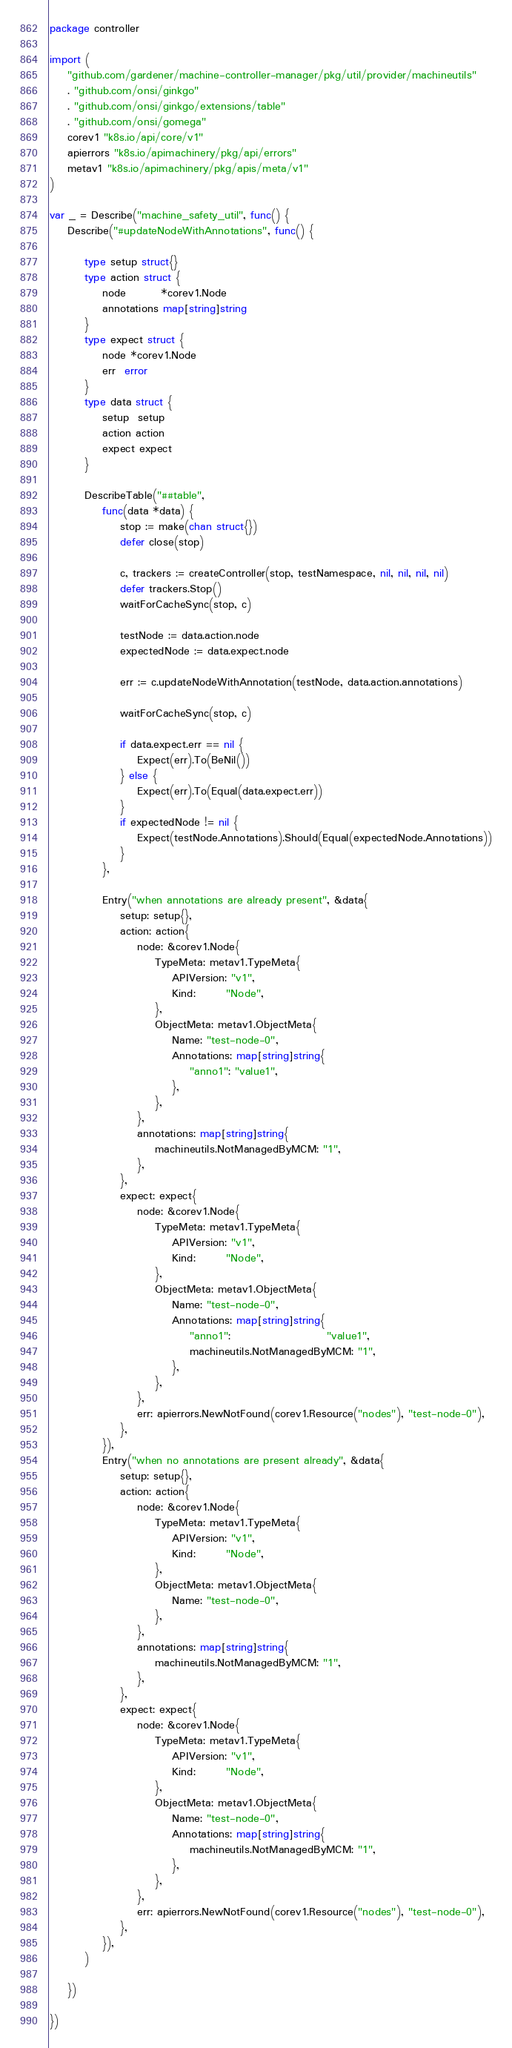<code> <loc_0><loc_0><loc_500><loc_500><_Go_>package controller

import (
	"github.com/gardener/machine-controller-manager/pkg/util/provider/machineutils"
	. "github.com/onsi/ginkgo"
	. "github.com/onsi/ginkgo/extensions/table"
	. "github.com/onsi/gomega"
	corev1 "k8s.io/api/core/v1"
	apierrors "k8s.io/apimachinery/pkg/api/errors"
	metav1 "k8s.io/apimachinery/pkg/apis/meta/v1"
)

var _ = Describe("machine_safety_util", func() {
	Describe("#updateNodeWithAnnotations", func() {

		type setup struct{}
		type action struct {
			node        *corev1.Node
			annotations map[string]string
		}
		type expect struct {
			node *corev1.Node
			err  error
		}
		type data struct {
			setup  setup
			action action
			expect expect
		}

		DescribeTable("##table",
			func(data *data) {
				stop := make(chan struct{})
				defer close(stop)

				c, trackers := createController(stop, testNamespace, nil, nil, nil, nil)
				defer trackers.Stop()
				waitForCacheSync(stop, c)

				testNode := data.action.node
				expectedNode := data.expect.node

				err := c.updateNodeWithAnnotation(testNode, data.action.annotations)

				waitForCacheSync(stop, c)

				if data.expect.err == nil {
					Expect(err).To(BeNil())
				} else {
					Expect(err).To(Equal(data.expect.err))
				}
				if expectedNode != nil {
					Expect(testNode.Annotations).Should(Equal(expectedNode.Annotations))
				}
			},

			Entry("when annotations are already present", &data{
				setup: setup{},
				action: action{
					node: &corev1.Node{
						TypeMeta: metav1.TypeMeta{
							APIVersion: "v1",
							Kind:       "Node",
						},
						ObjectMeta: metav1.ObjectMeta{
							Name: "test-node-0",
							Annotations: map[string]string{
								"anno1": "value1",
							},
						},
					},
					annotations: map[string]string{
						machineutils.NotManagedByMCM: "1",
					},
				},
				expect: expect{
					node: &corev1.Node{
						TypeMeta: metav1.TypeMeta{
							APIVersion: "v1",
							Kind:       "Node",
						},
						ObjectMeta: metav1.ObjectMeta{
							Name: "test-node-0",
							Annotations: map[string]string{
								"anno1":                      "value1",
								machineutils.NotManagedByMCM: "1",
							},
						},
					},
					err: apierrors.NewNotFound(corev1.Resource("nodes"), "test-node-0"),
				},
			}),
			Entry("when no annotations are present already", &data{
				setup: setup{},
				action: action{
					node: &corev1.Node{
						TypeMeta: metav1.TypeMeta{
							APIVersion: "v1",
							Kind:       "Node",
						},
						ObjectMeta: metav1.ObjectMeta{
							Name: "test-node-0",
						},
					},
					annotations: map[string]string{
						machineutils.NotManagedByMCM: "1",
					},
				},
				expect: expect{
					node: &corev1.Node{
						TypeMeta: metav1.TypeMeta{
							APIVersion: "v1",
							Kind:       "Node",
						},
						ObjectMeta: metav1.ObjectMeta{
							Name: "test-node-0",
							Annotations: map[string]string{
								machineutils.NotManagedByMCM: "1",
							},
						},
					},
					err: apierrors.NewNotFound(corev1.Resource("nodes"), "test-node-0"),
				},
			}),
		)

	})

})
</code> 